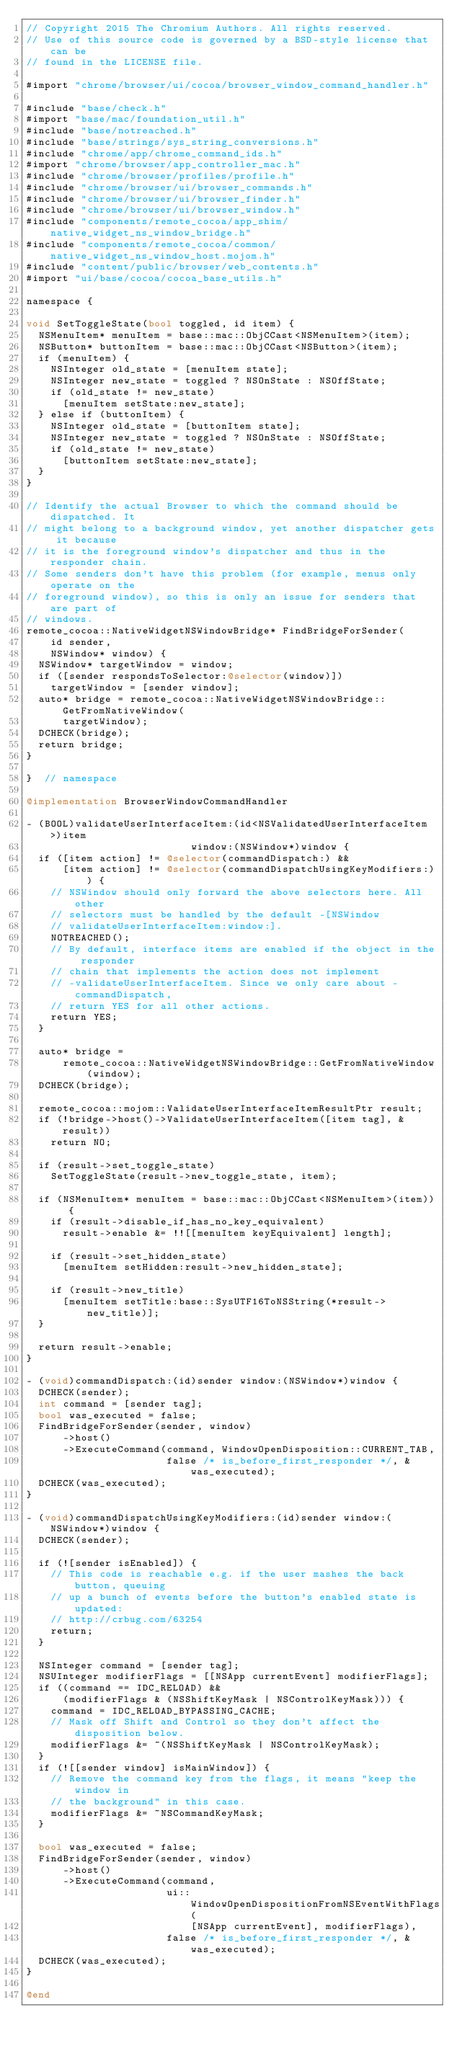<code> <loc_0><loc_0><loc_500><loc_500><_ObjectiveC_>// Copyright 2015 The Chromium Authors. All rights reserved.
// Use of this source code is governed by a BSD-style license that can be
// found in the LICENSE file.

#import "chrome/browser/ui/cocoa/browser_window_command_handler.h"

#include "base/check.h"
#import "base/mac/foundation_util.h"
#include "base/notreached.h"
#include "base/strings/sys_string_conversions.h"
#include "chrome/app/chrome_command_ids.h"
#import "chrome/browser/app_controller_mac.h"
#include "chrome/browser/profiles/profile.h"
#include "chrome/browser/ui/browser_commands.h"
#include "chrome/browser/ui/browser_finder.h"
#include "chrome/browser/ui/browser_window.h"
#include "components/remote_cocoa/app_shim/native_widget_ns_window_bridge.h"
#include "components/remote_cocoa/common/native_widget_ns_window_host.mojom.h"
#include "content/public/browser/web_contents.h"
#import "ui/base/cocoa/cocoa_base_utils.h"

namespace {

void SetToggleState(bool toggled, id item) {
  NSMenuItem* menuItem = base::mac::ObjCCast<NSMenuItem>(item);
  NSButton* buttonItem = base::mac::ObjCCast<NSButton>(item);
  if (menuItem) {
    NSInteger old_state = [menuItem state];
    NSInteger new_state = toggled ? NSOnState : NSOffState;
    if (old_state != new_state)
      [menuItem setState:new_state];
  } else if (buttonItem) {
    NSInteger old_state = [buttonItem state];
    NSInteger new_state = toggled ? NSOnState : NSOffState;
    if (old_state != new_state)
      [buttonItem setState:new_state];
  }
}

// Identify the actual Browser to which the command should be dispatched. It
// might belong to a background window, yet another dispatcher gets it because
// it is the foreground window's dispatcher and thus in the responder chain.
// Some senders don't have this problem (for example, menus only operate on the
// foreground window), so this is only an issue for senders that are part of
// windows.
remote_cocoa::NativeWidgetNSWindowBridge* FindBridgeForSender(
    id sender,
    NSWindow* window) {
  NSWindow* targetWindow = window;
  if ([sender respondsToSelector:@selector(window)])
    targetWindow = [sender window];
  auto* bridge = remote_cocoa::NativeWidgetNSWindowBridge::GetFromNativeWindow(
      targetWindow);
  DCHECK(bridge);
  return bridge;
}

}  // namespace

@implementation BrowserWindowCommandHandler

- (BOOL)validateUserInterfaceItem:(id<NSValidatedUserInterfaceItem>)item
                           window:(NSWindow*)window {
  if ([item action] != @selector(commandDispatch:) &&
      [item action] != @selector(commandDispatchUsingKeyModifiers:)) {
    // NSWindow should only forward the above selectors here. All other
    // selectors must be handled by the default -[NSWindow
    // validateUserInterfaceItem:window:].
    NOTREACHED();
    // By default, interface items are enabled if the object in the responder
    // chain that implements the action does not implement
    // -validateUserInterfaceItem. Since we only care about -commandDispatch,
    // return YES for all other actions.
    return YES;
  }

  auto* bridge =
      remote_cocoa::NativeWidgetNSWindowBridge::GetFromNativeWindow(window);
  DCHECK(bridge);

  remote_cocoa::mojom::ValidateUserInterfaceItemResultPtr result;
  if (!bridge->host()->ValidateUserInterfaceItem([item tag], &result))
    return NO;

  if (result->set_toggle_state)
    SetToggleState(result->new_toggle_state, item);

  if (NSMenuItem* menuItem = base::mac::ObjCCast<NSMenuItem>(item)) {
    if (result->disable_if_has_no_key_equivalent)
      result->enable &= !![[menuItem keyEquivalent] length];

    if (result->set_hidden_state)
      [menuItem setHidden:result->new_hidden_state];

    if (result->new_title)
      [menuItem setTitle:base::SysUTF16ToNSString(*result->new_title)];
  }

  return result->enable;
}

- (void)commandDispatch:(id)sender window:(NSWindow*)window {
  DCHECK(sender);
  int command = [sender tag];
  bool was_executed = false;
  FindBridgeForSender(sender, window)
      ->host()
      ->ExecuteCommand(command, WindowOpenDisposition::CURRENT_TAB,
                       false /* is_before_first_responder */, &was_executed);
  DCHECK(was_executed);
}

- (void)commandDispatchUsingKeyModifiers:(id)sender window:(NSWindow*)window {
  DCHECK(sender);

  if (![sender isEnabled]) {
    // This code is reachable e.g. if the user mashes the back button, queuing
    // up a bunch of events before the button's enabled state is updated:
    // http://crbug.com/63254
    return;
  }

  NSInteger command = [sender tag];
  NSUInteger modifierFlags = [[NSApp currentEvent] modifierFlags];
  if ((command == IDC_RELOAD) &&
      (modifierFlags & (NSShiftKeyMask | NSControlKeyMask))) {
    command = IDC_RELOAD_BYPASSING_CACHE;
    // Mask off Shift and Control so they don't affect the disposition below.
    modifierFlags &= ~(NSShiftKeyMask | NSControlKeyMask);
  }
  if (![[sender window] isMainWindow]) {
    // Remove the command key from the flags, it means "keep the window in
    // the background" in this case.
    modifierFlags &= ~NSCommandKeyMask;
  }

  bool was_executed = false;
  FindBridgeForSender(sender, window)
      ->host()
      ->ExecuteCommand(command,
                       ui::WindowOpenDispositionFromNSEventWithFlags(
                           [NSApp currentEvent], modifierFlags),
                       false /* is_before_first_responder */, &was_executed);
  DCHECK(was_executed);
}

@end
</code> 